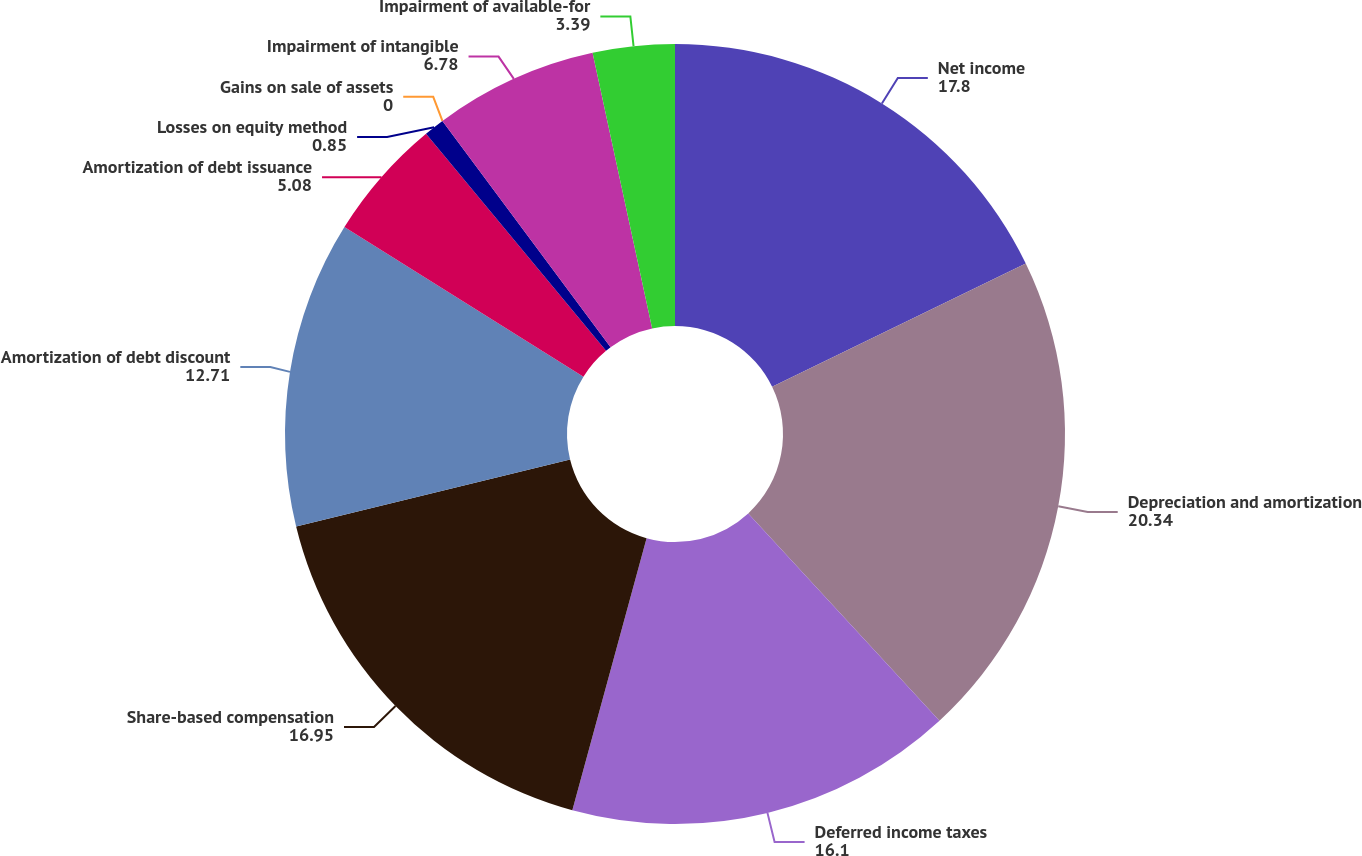<chart> <loc_0><loc_0><loc_500><loc_500><pie_chart><fcel>Net income<fcel>Depreciation and amortization<fcel>Deferred income taxes<fcel>Share-based compensation<fcel>Amortization of debt discount<fcel>Amortization of debt issuance<fcel>Losses on equity method<fcel>Gains on sale of assets<fcel>Impairment of intangible<fcel>Impairment of available-for<nl><fcel>17.8%<fcel>20.34%<fcel>16.1%<fcel>16.95%<fcel>12.71%<fcel>5.08%<fcel>0.85%<fcel>0.0%<fcel>6.78%<fcel>3.39%<nl></chart> 